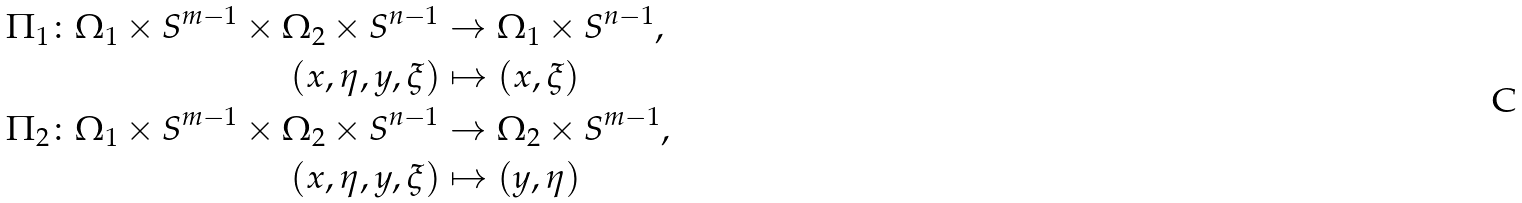<formula> <loc_0><loc_0><loc_500><loc_500>\Pi _ { 1 } \colon \Omega _ { 1 } \times S ^ { m - 1 } \times \Omega _ { 2 } \times S ^ { n - 1 } & \rightarrow \Omega _ { 1 } \times S ^ { n - 1 } , \\ ( x , \eta , y , \xi ) & \mapsto ( x , \xi ) \\ \Pi _ { 2 } \colon \Omega _ { 1 } \times S ^ { m - 1 } \times \Omega _ { 2 } \times S ^ { n - 1 } & \rightarrow \Omega _ { 2 } \times S ^ { m - 1 } , \\ ( x , \eta , y , \xi ) & \mapsto ( y , \eta )</formula> 